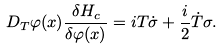<formula> <loc_0><loc_0><loc_500><loc_500>D _ { T } \varphi ( x ) \frac { \delta H _ { c } } { \delta \varphi ( x ) } = i T \dot { \sigma } + \frac { i } { 2 } \dot { T } \sigma .</formula> 